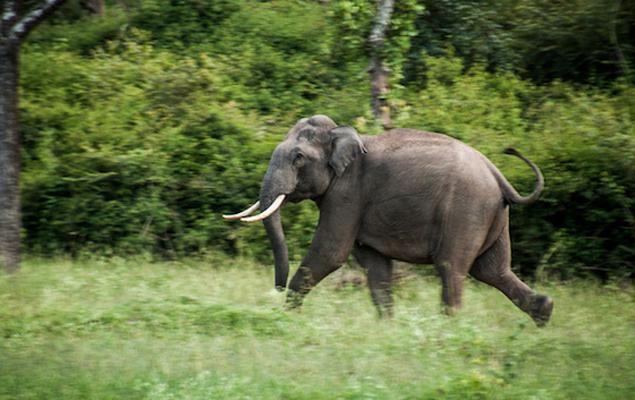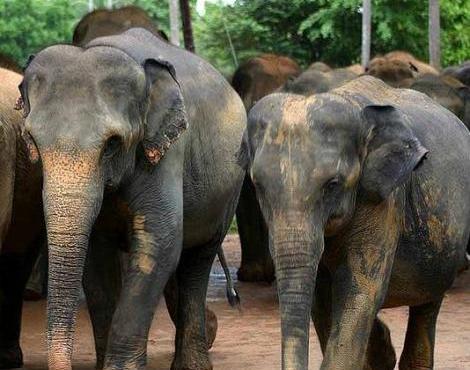The first image is the image on the left, the second image is the image on the right. Assess this claim about the two images: "Several elephants are in the water.". Correct or not? Answer yes or no. No. The first image is the image on the left, the second image is the image on the right. Assess this claim about the two images: "An image shows at least ten elephants completely surrounded by water.". Correct or not? Answer yes or no. No. 